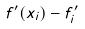Convert formula to latex. <formula><loc_0><loc_0><loc_500><loc_500>f ^ { \prime } ( x _ { i } ) - f _ { i } ^ { \prime }</formula> 